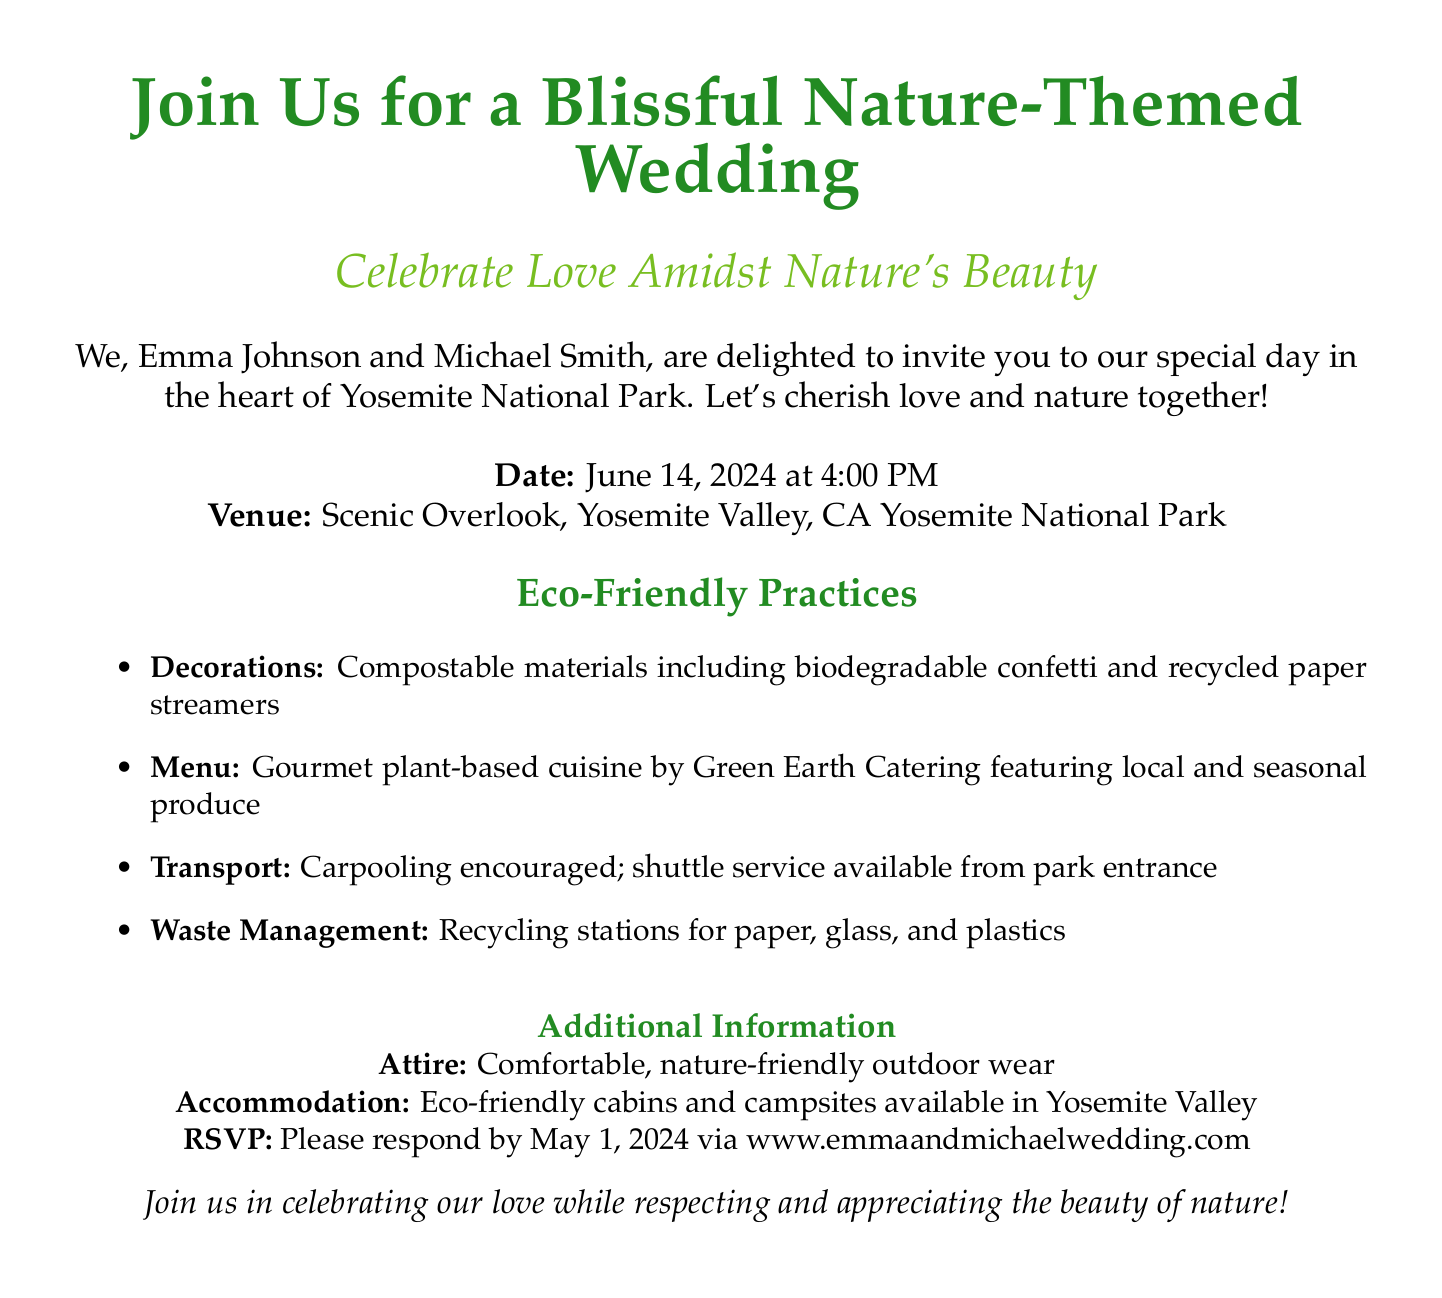What is the venue for the wedding? The venue is specified in the document as "Scenic Overlook, Yosemite Valley, CA, Yosemite National Park."
Answer: Scenic Overlook, Yosemite Valley, CA What date is the wedding scheduled? The invitation clearly states the date of the wedding as June 14, 2024.
Answer: June 14, 2024 What type of cuisine will be served at the wedding? The menu details indicate that gourmet plant-based cuisine will be provided, emphasizing the ecological theme.
Answer: Plant-based cuisine What should guests do regarding transportation? The document suggests carpooling and mentions that a shuttle service is available, indicating eco-friendly practices.
Answer: Carpooling encouraged What is the RSVP deadline? The deadline for RSVPs is noted in the text, specifically asking guests to respond by May 1, 2024.
Answer: May 1, 2024 What type of decorations will be used? The invitation outlines that decorations will include compostable materials, highlighting the wedding’s eco-friendly nature.
Answer: Compostable materials What is recommended attire for the guests? The document suggests that guests wear comfortable, nature-friendly outdoor wear to align with the event's theme.
Answer: Comfortable, nature-friendly outdoor wear What season will the wedding take place? The wedding is scheduled for June, which falls in the summer season.
Answer: Summer What is the focus of this wedding invitation? The overall theme highlighted in the document is clearly centered around love and nature conservation practices.
Answer: Nature-Themed Wedding 